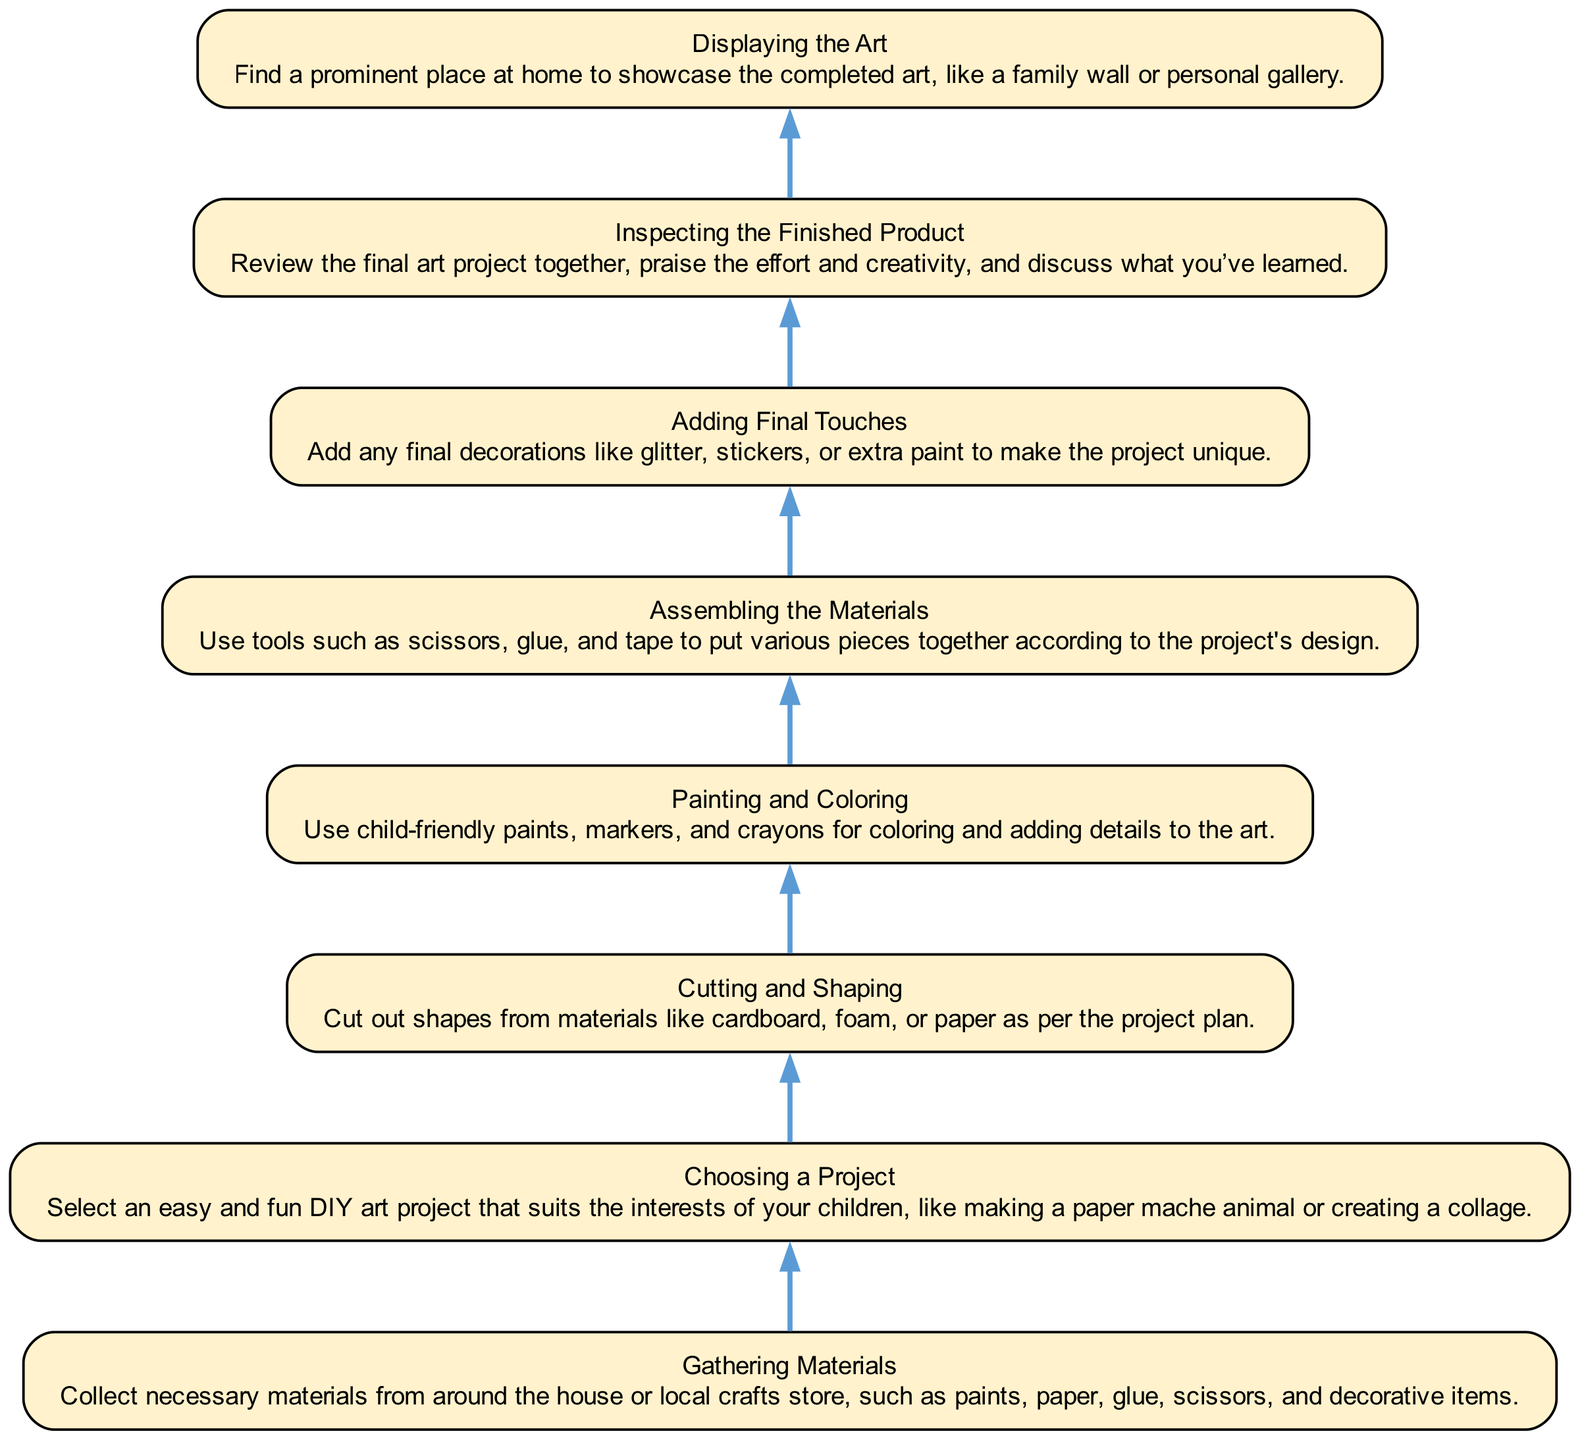What is the first step in the DIY art project? The first step, situated at the bottom of the diagram, is "Gathering Materials." This node indicates the starting point before any crafting takes place.
Answer: Gathering Materials How many total nodes are in the diagram? By counting each unique step in the flow chart, we find that there are a total of eight nodes, beginning with "Gathering Materials" and ending with "Displaying the Art."
Answer: Eight What comes after "Choosing a Project" in the flow? In the flow of the diagram, "Gathering Materials" directly follows "Choosing a Project," indicating that after picking a project, you need to gather supplies for it.
Answer: Gathering Materials What is the last step in the DIY art project? The last step, positioned at the top of the diagram, is "Displaying the Art." This step involves showcasing the completed piece, indicating the conclusion of the crafting process.
Answer: Displaying the Art Which step involves using tools like scissors and glue? "Assembling the Materials" is the step where tools like scissors and glue are used to put various pieces together, signifying an active crafting phase in the process.
Answer: Assembling the Materials What two actions are done after painting and coloring the project? Following "Painting and Coloring," the diagram instructs to "Adding Final Touches" and then to "Inspecting the Finished Product," which involves adding details and reviewing the artwork together.
Answer: Adding Final Touches, Inspecting the Finished Product Which step directly leads to displaying the artwork? "Inspecting the Finished Product" directly precedes "Displaying the Art," indicating that the review of the artwork is necessary before it can be showcased.
Answer: Inspecting the Finished Product What type of projects should be selected initially? The initial project selected should be "easy and fun DIY art projects," as stated in the "Choosing a Project" step. This ensures the project aligns with the children's interests.
Answer: Easy and fun DIY art projects 